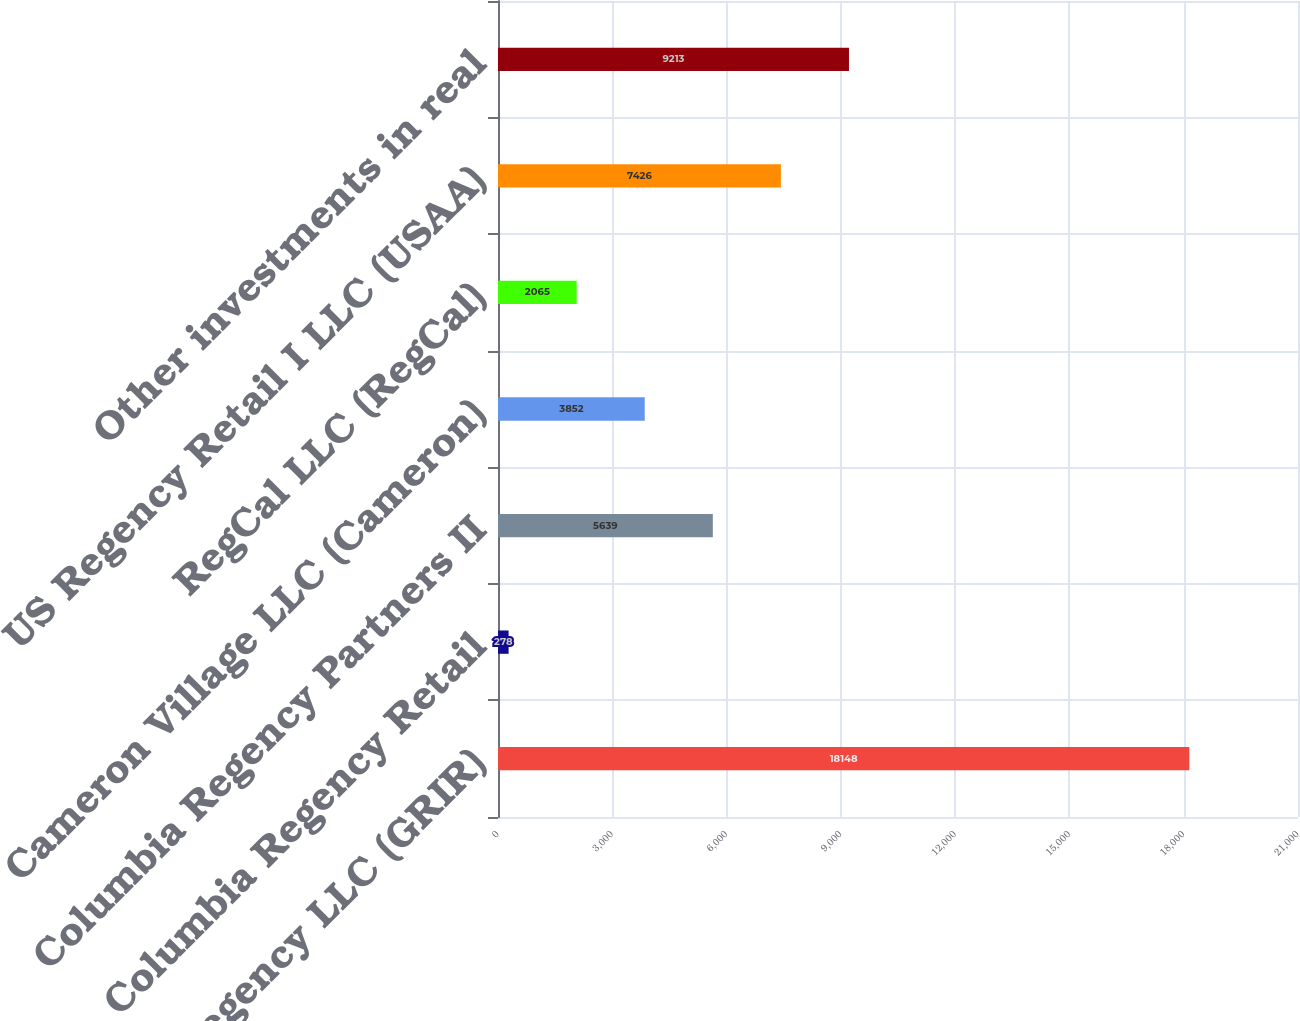Convert chart. <chart><loc_0><loc_0><loc_500><loc_500><bar_chart><fcel>GRI - Regency LLC (GRIR)<fcel>Columbia Regency Retail<fcel>Columbia Regency Partners II<fcel>Cameron Village LLC (Cameron)<fcel>RegCal LLC (RegCal)<fcel>US Regency Retail I LLC (USAA)<fcel>Other investments in real<nl><fcel>18148<fcel>278<fcel>5639<fcel>3852<fcel>2065<fcel>7426<fcel>9213<nl></chart> 